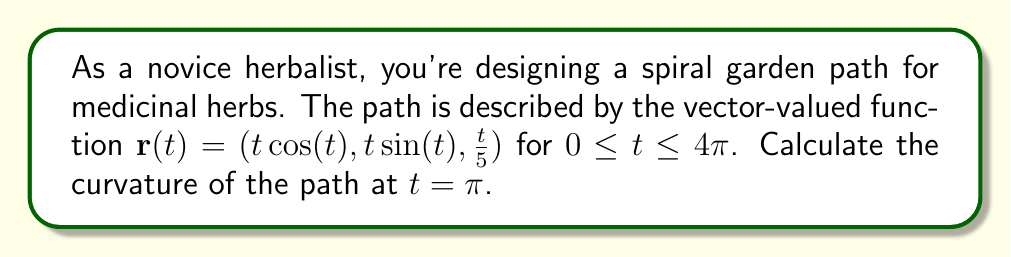Can you solve this math problem? To find the curvature of the spiral herb garden path, we'll use the formula for curvature of a vector-valued function:

$$\kappa = \frac{|\mathbf{r}'(t) \times \mathbf{r}''(t)|}{|\mathbf{r}'(t)|^3}$$

Let's proceed step by step:

1) First, we need to find $\mathbf{r}'(t)$:
   $$\mathbf{r}'(t) = (\cos(t) - t\sin(t), \sin(t) + t\cos(t), \frac{1}{5})$$

2) Next, we calculate $\mathbf{r}''(t)$:
   $$\mathbf{r}''(t) = (-2\sin(t) - t\cos(t), 2\cos(t) - t\sin(t), 0)$$

3) Now, let's evaluate these at $t = \pi$:
   $$\mathbf{r}'(\pi) = (-\pi, 1, \frac{1}{5})$$
   $$\mathbf{r}''(\pi) = (-\pi, -2, 0)$$

4) We need to calculate the cross product $\mathbf{r}'(\pi) \times \mathbf{r}''(\pi)$:
   $$\mathbf{r}'(\pi) \times \mathbf{r}''(\pi) = \left(\frac{2}{5}, \frac{\pi}{5}, 2\pi - 1\right)$$

5) Now we can calculate the magnitudes:
   $$|\mathbf{r}'(\pi) \times \mathbf{r}''(\pi)| = \sqrt{(\frac{2}{5})^2 + (\frac{\pi}{5})^2 + (2\pi - 1)^2}$$
   $$|\mathbf{r}'(\pi)| = \sqrt{\pi^2 + 1 + (\frac{1}{5})^2}$$

6) Finally, we can plug these into our curvature formula:
   $$\kappa = \frac{\sqrt{(\frac{2}{5})^2 + (\frac{\pi}{5})^2 + (2\pi - 1)^2}}{(\sqrt{\pi^2 + 1 + (\frac{1}{5})^2})^3}$$

This is the curvature of your spiral herb garden path at $t = \pi$.
Answer: $$\kappa = \frac{\sqrt{(\frac{2}{5})^2 + (\frac{\pi}{5})^2 + (2\pi - 1)^2}}{(\sqrt{\pi^2 + 1 + (\frac{1}{5})^2})^3}$$ 